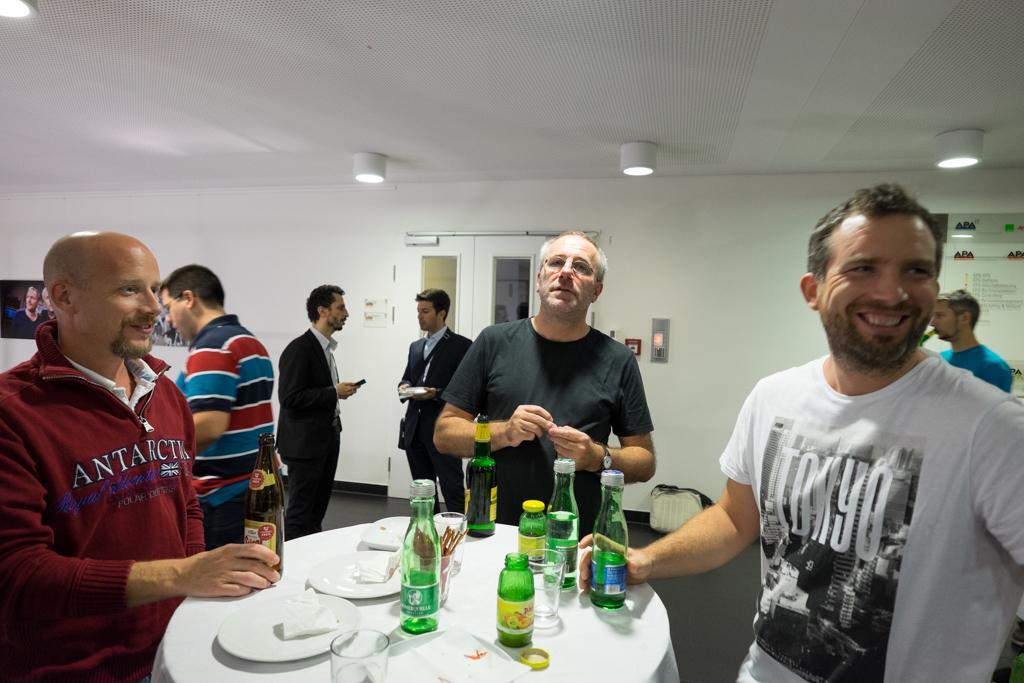Can you describe this image briefly? In the image it looks like a party on the table there are some food items and the bottles around the table three men standing behind them there are also few other men in the background there is a white wall there is a door to the left side to the wall there is television there is also some poster to the wall, to the roof there are few lights. 